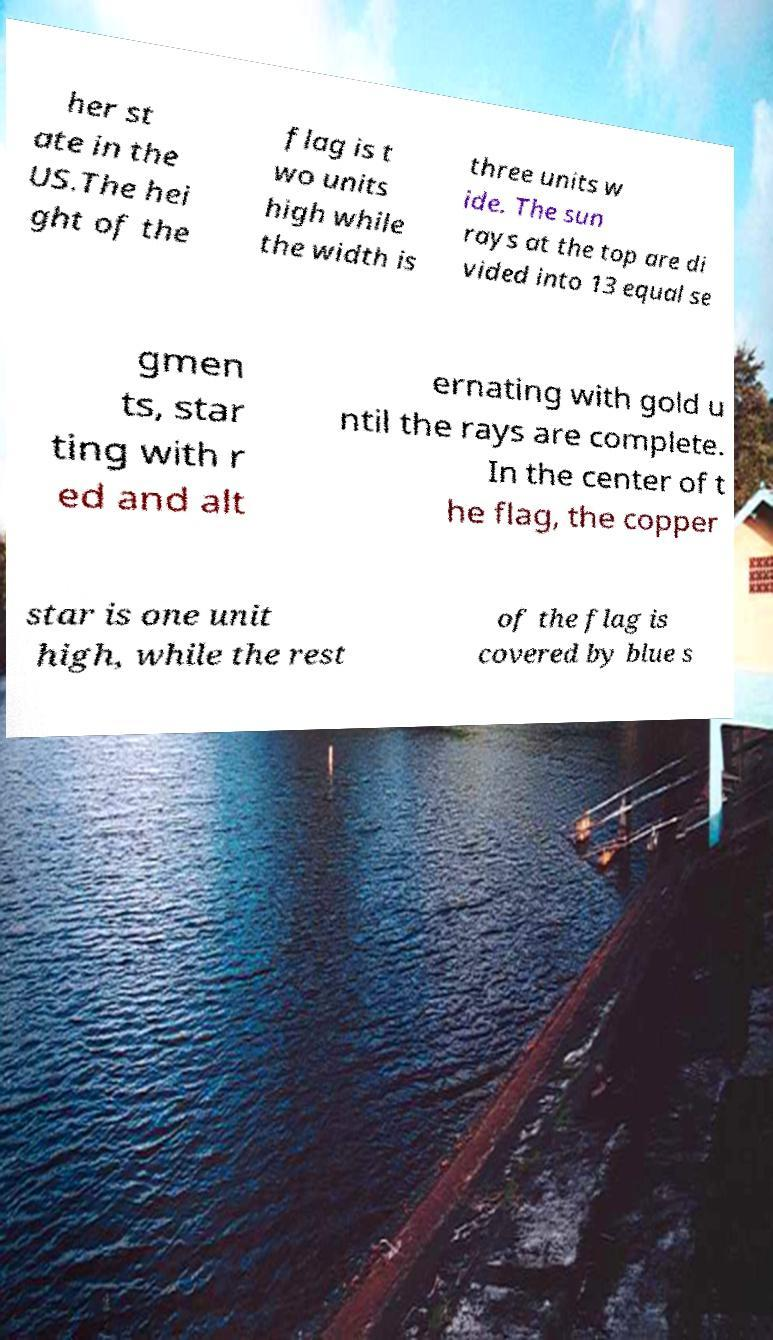For documentation purposes, I need the text within this image transcribed. Could you provide that? her st ate in the US.The hei ght of the flag is t wo units high while the width is three units w ide. The sun rays at the top are di vided into 13 equal se gmen ts, star ting with r ed and alt ernating with gold u ntil the rays are complete. In the center of t he flag, the copper star is one unit high, while the rest of the flag is covered by blue s 